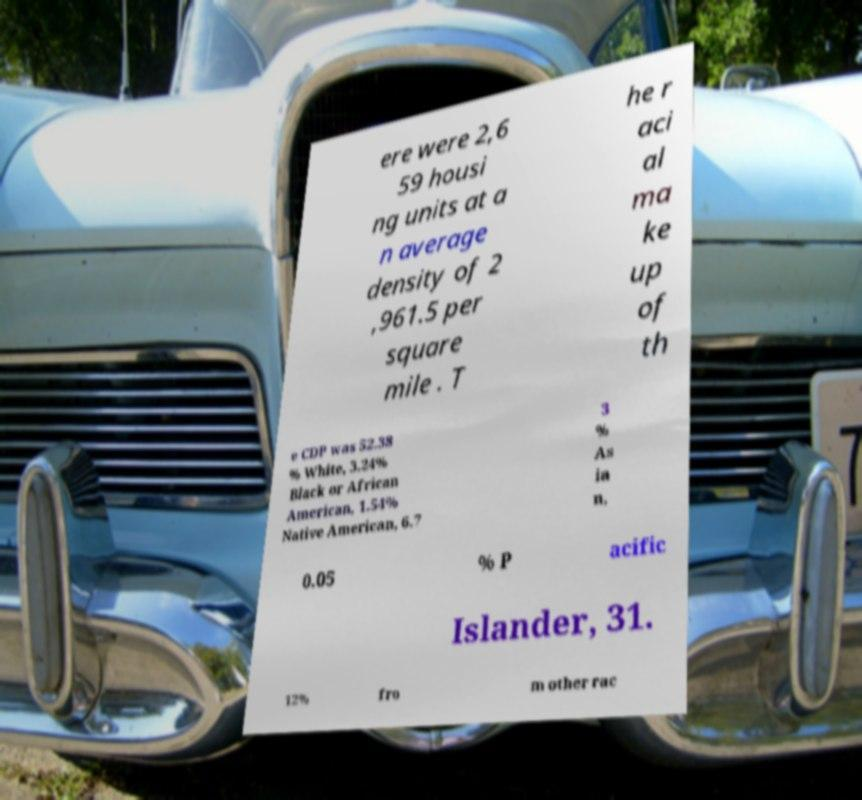Please read and relay the text visible in this image. What does it say? ere were 2,6 59 housi ng units at a n average density of 2 ,961.5 per square mile . T he r aci al ma ke up of th e CDP was 52.38 % White, 3.24% Black or African American, 1.54% Native American, 6.7 3 % As ia n, 0.05 % P acific Islander, 31. 12% fro m other rac 